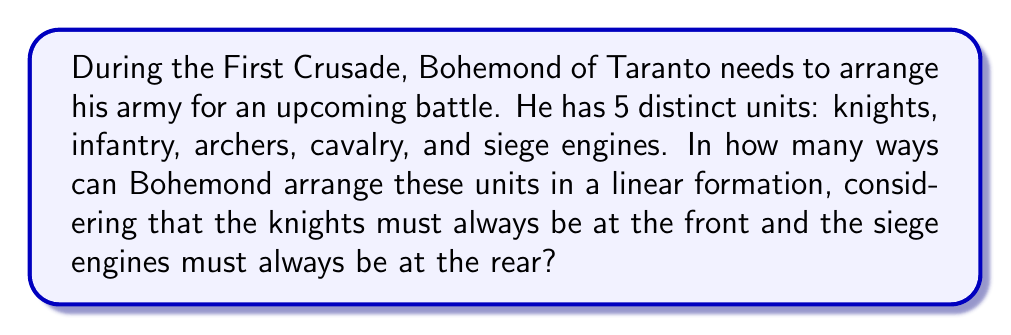Can you solve this math problem? Let's approach this step-by-step using permutation groups:

1) We have 5 distinct units, but two of them have fixed positions:
   - Knights must be at the front (position 1)
   - Siege engines must be at the rear (position 5)

2) This leaves us with 3 units (infantry, archers, and cavalry) that can be arranged in the middle 3 positions.

3) The number of ways to arrange 3 distinct objects is given by the permutation formula:

   $$P(3,3) = 3! = 3 \times 2 \times 1 = 6$$

4) We can think of this as a permutation group $S_3$, which has order 6.

5) The possible arrangements can be represented as elements of $S_3$:
   $$(1), (12), (13), (23), (123), (132)$$
   where 1 could represent infantry, 2 archers, and 3 cavalry.

6) Each of these 6 permutations represents a unique arrangement of the middle 3 units, while the knights and siege engines remain fixed at the ends.

Therefore, there are 6 possible ways to arrange the army units under these constraints.
Answer: 6 possible arrangements 